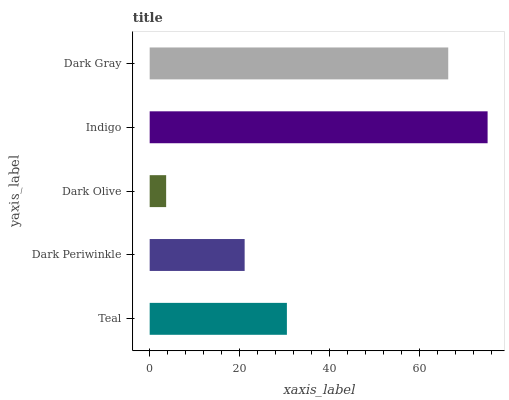Is Dark Olive the minimum?
Answer yes or no. Yes. Is Indigo the maximum?
Answer yes or no. Yes. Is Dark Periwinkle the minimum?
Answer yes or no. No. Is Dark Periwinkle the maximum?
Answer yes or no. No. Is Teal greater than Dark Periwinkle?
Answer yes or no. Yes. Is Dark Periwinkle less than Teal?
Answer yes or no. Yes. Is Dark Periwinkle greater than Teal?
Answer yes or no. No. Is Teal less than Dark Periwinkle?
Answer yes or no. No. Is Teal the high median?
Answer yes or no. Yes. Is Teal the low median?
Answer yes or no. Yes. Is Dark Gray the high median?
Answer yes or no. No. Is Indigo the low median?
Answer yes or no. No. 